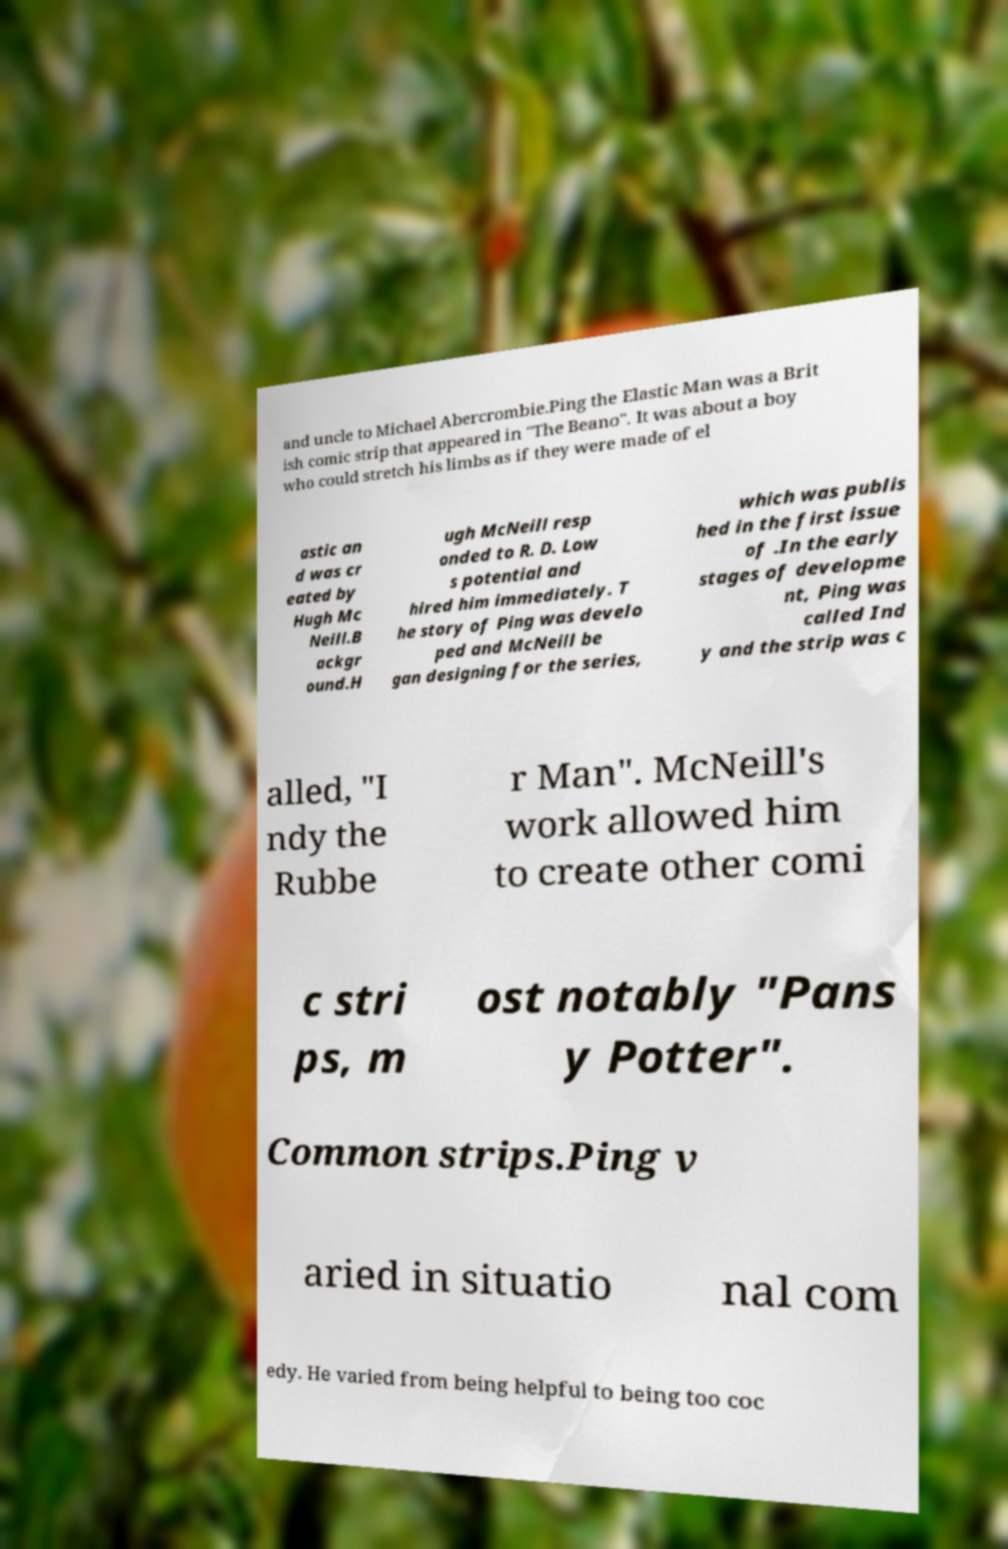There's text embedded in this image that I need extracted. Can you transcribe it verbatim? and uncle to Michael Abercrombie.Ping the Elastic Man was a Brit ish comic strip that appeared in "The Beano". It was about a boy who could stretch his limbs as if they were made of el astic an d was cr eated by Hugh Mc Neill.B ackgr ound.H ugh McNeill resp onded to R. D. Low s potential and hired him immediately. T he story of Ping was develo ped and McNeill be gan designing for the series, which was publis hed in the first issue of .In the early stages of developme nt, Ping was called Ind y and the strip was c alled, "I ndy the Rubbe r Man". McNeill's work allowed him to create other comi c stri ps, m ost notably "Pans y Potter". Common strips.Ping v aried in situatio nal com edy. He varied from being helpful to being too coc 